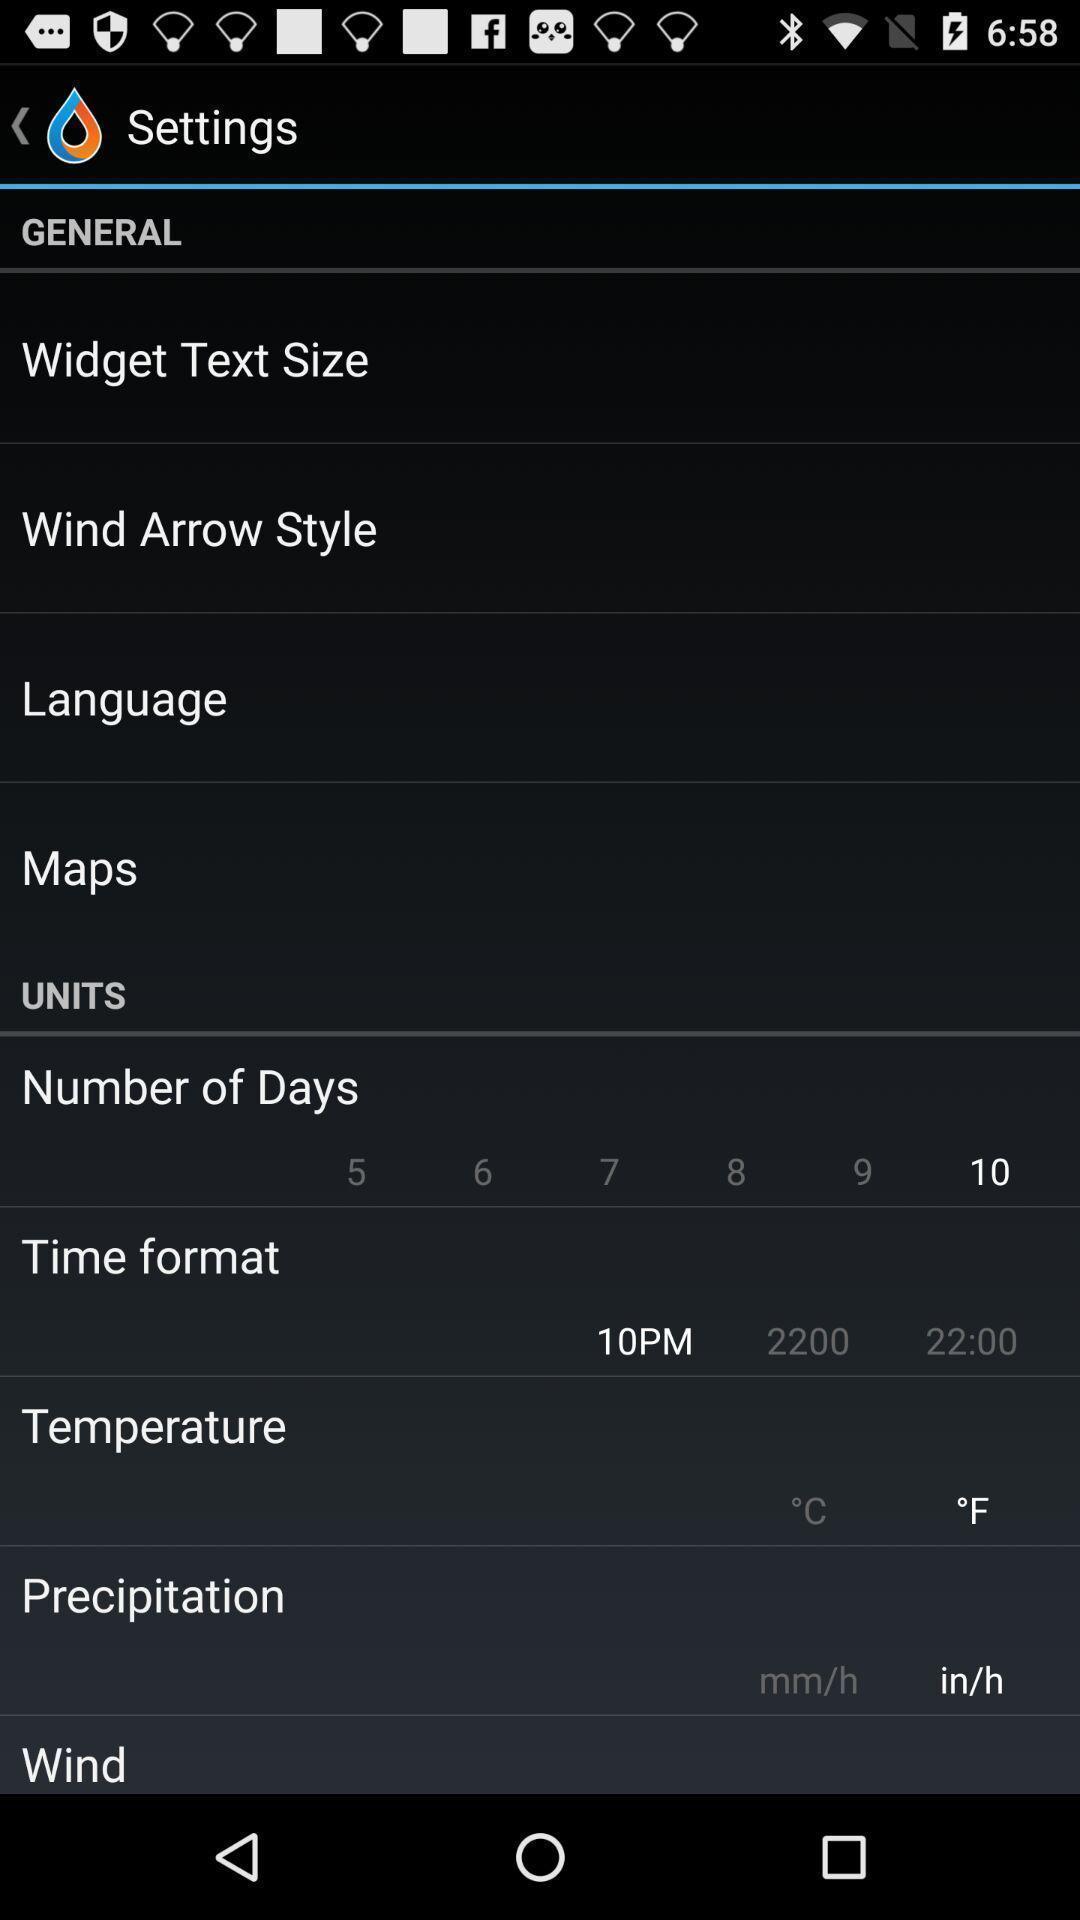What is the overall content of this screenshot? Settings page displaying multiple options. 